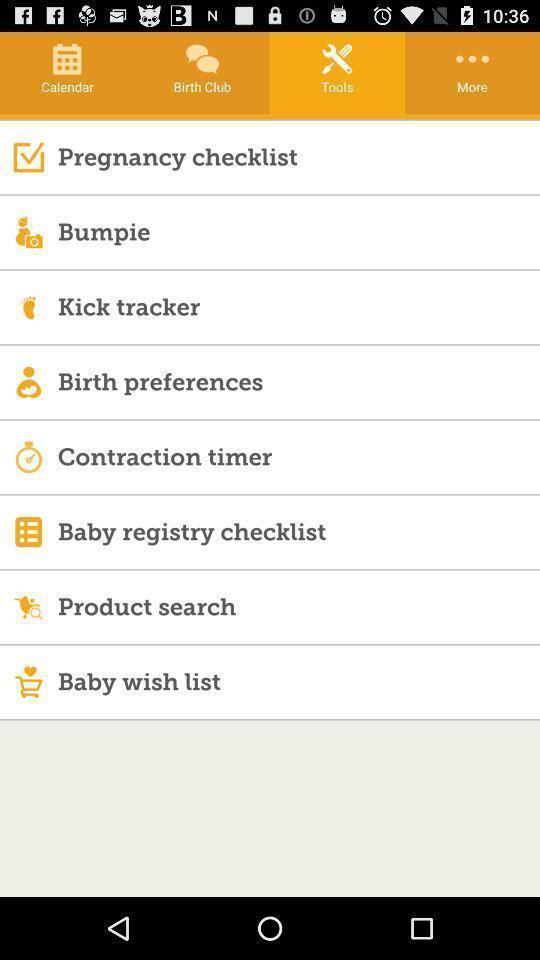Describe the content in this image. Page showing categories in a pregnancy tracker app. 